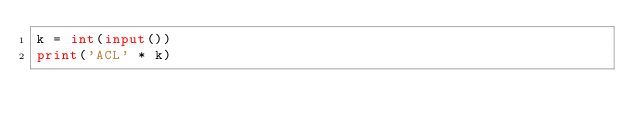Convert code to text. <code><loc_0><loc_0><loc_500><loc_500><_Python_>k = int(input())
print('ACL' * k)
</code> 